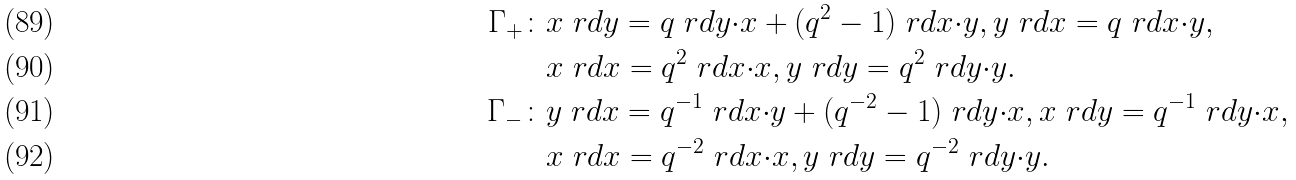<formula> <loc_0><loc_0><loc_500><loc_500>\Gamma _ { + } \colon & x \ r d y = q \ r d y { \cdot } x + ( q ^ { 2 } - 1 ) \ r d x { \cdot } y , y \ r d x = q \ r d x { \cdot } y , \\ & x \ r d x = q ^ { 2 } \ r d x { \cdot } x , y \ r d y = q ^ { 2 } \ r d y { \cdot } y . \\ \Gamma _ { - } \colon & y \ r d x = q ^ { - 1 } \ r d x { \cdot } y + ( q ^ { - 2 } - 1 ) \ r d y { \cdot } x , x \ r d y = q ^ { - 1 } \ r d y { \cdot } x , \\ & x \ r d x = q ^ { - 2 } \ r d x { \cdot } x , y \ r d y = q ^ { - 2 } \ r d y { \cdot } y .</formula> 